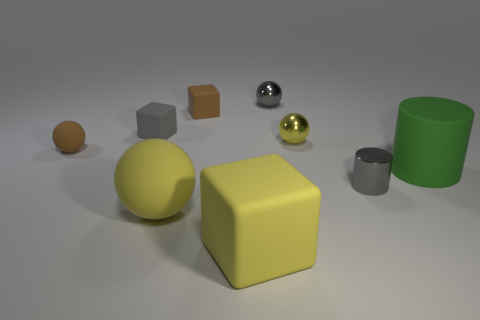What material is the tiny ball that is the same color as the big block?
Make the answer very short. Metal. How many yellow metal spheres are there?
Make the answer very short. 1. There is a tiny yellow metallic object; is it the same shape as the large yellow thing on the left side of the large rubber cube?
Offer a very short reply. Yes. What number of objects are either yellow matte objects or large things left of the green matte object?
Ensure brevity in your answer.  2. What material is the other thing that is the same shape as the green object?
Keep it short and to the point. Metal. There is a big object that is on the left side of the big yellow cube; is its shape the same as the green matte thing?
Make the answer very short. No. Are there fewer yellow metallic spheres that are in front of the large cylinder than yellow metallic spheres that are right of the small gray cube?
Your response must be concise. Yes. How many other objects are the same shape as the gray rubber thing?
Give a very brief answer. 2. What size is the gray object that is in front of the metallic sphere in front of the gray shiny thing left of the yellow shiny sphere?
Give a very brief answer. Small. How many green objects are either metallic objects or matte cylinders?
Keep it short and to the point. 1. 